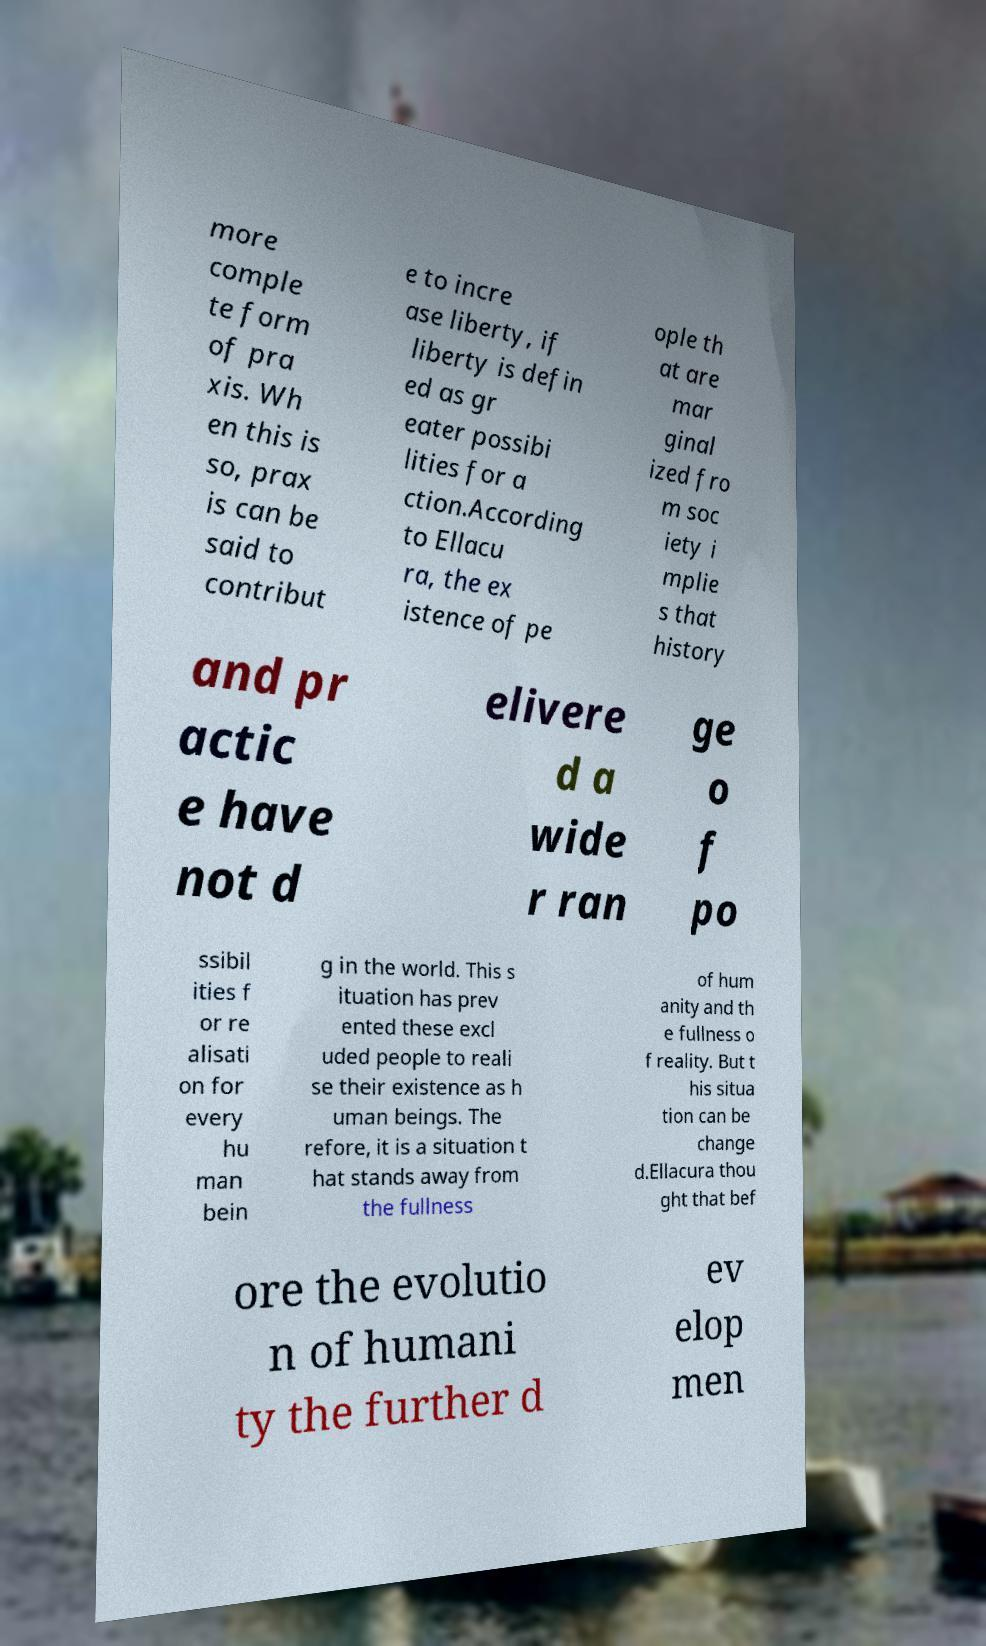Could you extract and type out the text from this image? more comple te form of pra xis. Wh en this is so, prax is can be said to contribut e to incre ase liberty, if liberty is defin ed as gr eater possibi lities for a ction.According to Ellacu ra, the ex istence of pe ople th at are mar ginal ized fro m soc iety i mplie s that history and pr actic e have not d elivere d a wide r ran ge o f po ssibil ities f or re alisati on for every hu man bein g in the world. This s ituation has prev ented these excl uded people to reali se their existence as h uman beings. The refore, it is a situation t hat stands away from the fullness of hum anity and th e fullness o f reality. But t his situa tion can be change d.Ellacura thou ght that bef ore the evolutio n of humani ty the further d ev elop men 